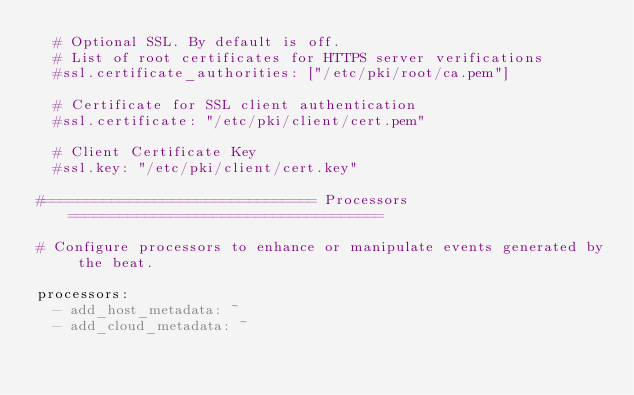Convert code to text. <code><loc_0><loc_0><loc_500><loc_500><_YAML_>  # Optional SSL. By default is off.
  # List of root certificates for HTTPS server verifications
  #ssl.certificate_authorities: ["/etc/pki/root/ca.pem"]

  # Certificate for SSL client authentication
  #ssl.certificate: "/etc/pki/client/cert.pem"

  # Client Certificate Key
  #ssl.key: "/etc/pki/client/cert.key"

#================================ Processors =====================================

# Configure processors to enhance or manipulate events generated by the beat.

processors:
  - add_host_metadata: ~
  - add_cloud_metadata: ~
</code> 